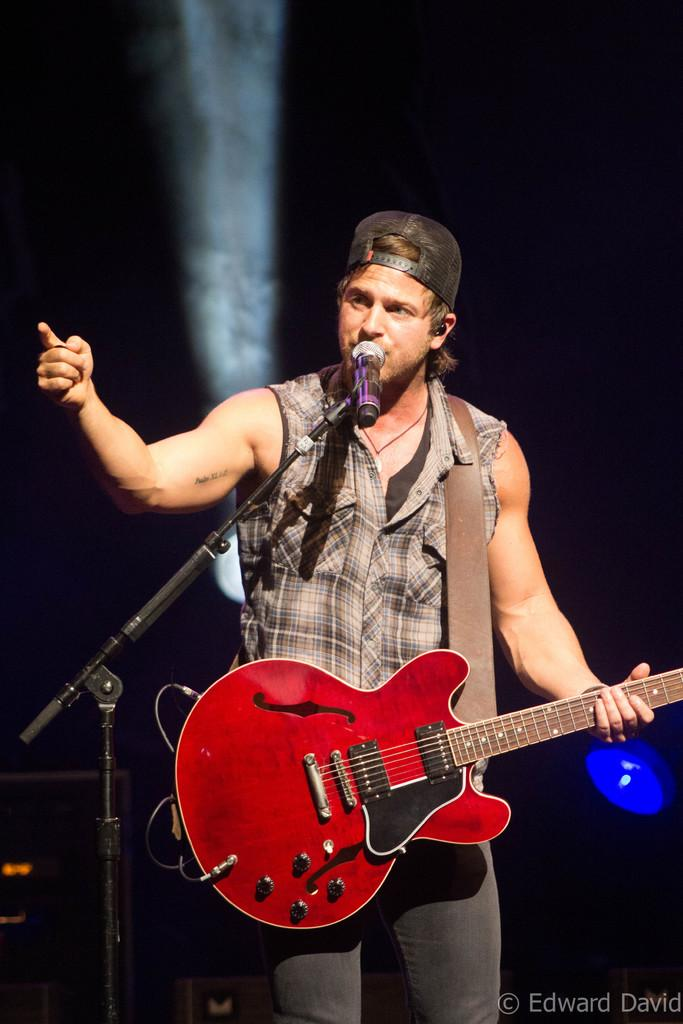What is the main subject of the image? There is a person in the image. What is the person wearing on their head? The person is wearing a cap. What is the person doing in the image? The person is standing, holding a guitar, and singing in front of a mic. What type of ray can be seen swimming in the background of the image? There is no ray present in the image; it features a person playing a guitar and singing. 